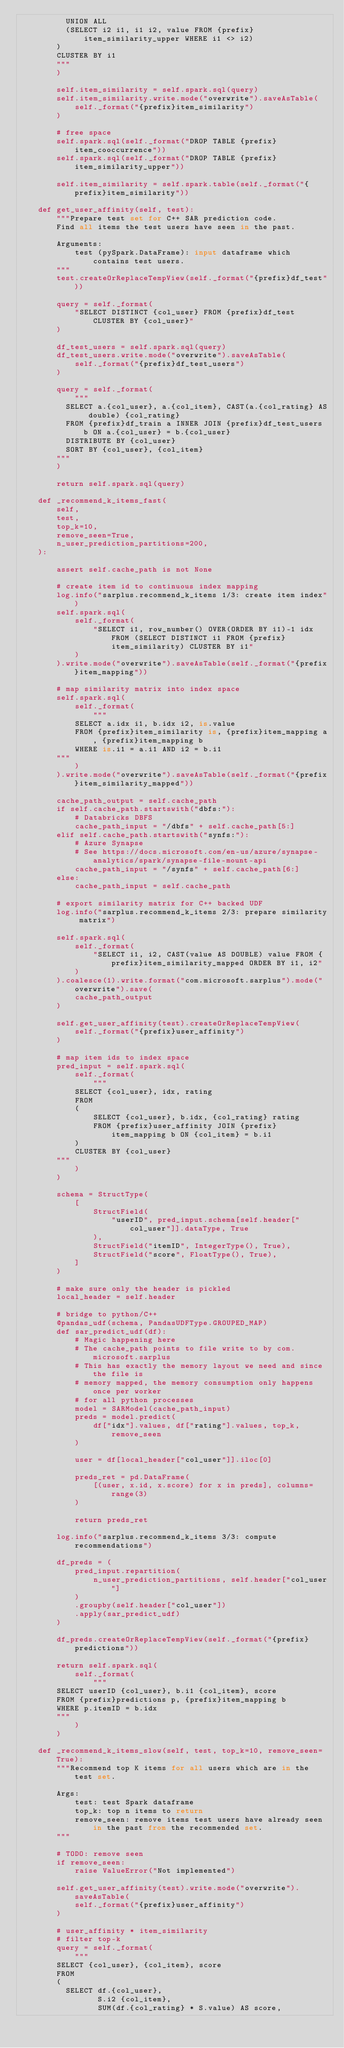<code> <loc_0><loc_0><loc_500><loc_500><_Python_>          UNION ALL
          (SELECT i2 i1, i1 i2, value FROM {prefix}item_similarity_upper WHERE i1 <> i2)
        )
        CLUSTER BY i1
        """
        )

        self.item_similarity = self.spark.sql(query)
        self.item_similarity.write.mode("overwrite").saveAsTable(
            self._format("{prefix}item_similarity")
        )

        # free space
        self.spark.sql(self._format("DROP TABLE {prefix}item_cooccurrence"))
        self.spark.sql(self._format("DROP TABLE {prefix}item_similarity_upper"))

        self.item_similarity = self.spark.table(self._format("{prefix}item_similarity"))

    def get_user_affinity(self, test):
        """Prepare test set for C++ SAR prediction code.
        Find all items the test users have seen in the past.

        Arguments:
            test (pySpark.DataFrame): input dataframe which contains test users.
        """
        test.createOrReplaceTempView(self._format("{prefix}df_test"))

        query = self._format(
            "SELECT DISTINCT {col_user} FROM {prefix}df_test CLUSTER BY {col_user}"
        )

        df_test_users = self.spark.sql(query)
        df_test_users.write.mode("overwrite").saveAsTable(
            self._format("{prefix}df_test_users")
        )

        query = self._format(
            """
          SELECT a.{col_user}, a.{col_item}, CAST(a.{col_rating} AS double) {col_rating}
          FROM {prefix}df_train a INNER JOIN {prefix}df_test_users b ON a.{col_user} = b.{col_user} 
          DISTRIBUTE BY {col_user}
          SORT BY {col_user}, {col_item}          
        """
        )

        return self.spark.sql(query)

    def _recommend_k_items_fast(
        self,
        test,
        top_k=10,
        remove_seen=True,
        n_user_prediction_partitions=200,
    ):

        assert self.cache_path is not None

        # create item id to continuous index mapping
        log.info("sarplus.recommend_k_items 1/3: create item index")
        self.spark.sql(
            self._format(
                "SELECT i1, row_number() OVER(ORDER BY i1)-1 idx FROM (SELECT DISTINCT i1 FROM {prefix}item_similarity) CLUSTER BY i1"
            )
        ).write.mode("overwrite").saveAsTable(self._format("{prefix}item_mapping"))

        # map similarity matrix into index space
        self.spark.sql(
            self._format(
                """
            SELECT a.idx i1, b.idx i2, is.value
            FROM {prefix}item_similarity is, {prefix}item_mapping a, {prefix}item_mapping b
            WHERE is.i1 = a.i1 AND i2 = b.i1
        """
            )
        ).write.mode("overwrite").saveAsTable(self._format("{prefix}item_similarity_mapped"))

        cache_path_output = self.cache_path
        if self.cache_path.startswith("dbfs:"):
            # Databricks DBFS
            cache_path_input = "/dbfs" + self.cache_path[5:]
        elif self.cache_path.startswith("synfs:"):
            # Azure Synapse
            # See https://docs.microsoft.com/en-us/azure/synapse-analytics/spark/synapse-file-mount-api
            cache_path_input = "/synfs" + self.cache_path[6:]
        else:
            cache_path_input = self.cache_path

        # export similarity matrix for C++ backed UDF
        log.info("sarplus.recommend_k_items 2/3: prepare similarity matrix")

        self.spark.sql(
            self._format(
                "SELECT i1, i2, CAST(value AS DOUBLE) value FROM {prefix}item_similarity_mapped ORDER BY i1, i2"
            )
        ).coalesce(1).write.format("com.microsoft.sarplus").mode("overwrite").save(
            cache_path_output
        )

        self.get_user_affinity(test).createOrReplaceTempView(
            self._format("{prefix}user_affinity")
        )

        # map item ids to index space
        pred_input = self.spark.sql(
            self._format(
                """
            SELECT {col_user}, idx, rating
            FROM 
            (
                SELECT {col_user}, b.idx, {col_rating} rating
                FROM {prefix}user_affinity JOIN {prefix}item_mapping b ON {col_item} = b.i1 
            )
            CLUSTER BY {col_user}
        """
            )
        )

        schema = StructType(
            [
                StructField(
                    "userID", pred_input.schema[self.header["col_user"]].dataType, True
                ),
                StructField("itemID", IntegerType(), True),
                StructField("score", FloatType(), True),
            ]
        )

        # make sure only the header is pickled
        local_header = self.header

        # bridge to python/C++
        @pandas_udf(schema, PandasUDFType.GROUPED_MAP)
        def sar_predict_udf(df):
            # Magic happening here
            # The cache_path points to file write to by com.microsoft.sarplus
            # This has exactly the memory layout we need and since the file is
            # memory mapped, the memory consumption only happens once per worker
            # for all python processes
            model = SARModel(cache_path_input)
            preds = model.predict(
                df["idx"].values, df["rating"].values, top_k, remove_seen
            )

            user = df[local_header["col_user"]].iloc[0]

            preds_ret = pd.DataFrame(
                [(user, x.id, x.score) for x in preds], columns=range(3)
            )

            return preds_ret

        log.info("sarplus.recommend_k_items 3/3: compute recommendations")

        df_preds = (
            pred_input.repartition(
                n_user_prediction_partitions, self.header["col_user"]
            )
            .groupby(self.header["col_user"])
            .apply(sar_predict_udf)
        )

        df_preds.createOrReplaceTempView(self._format("{prefix}predictions"))

        return self.spark.sql(
            self._format(
                """
        SELECT userID {col_user}, b.i1 {col_item}, score
        FROM {prefix}predictions p, {prefix}item_mapping b
        WHERE p.itemID = b.idx
        """
            )
        )

    def _recommend_k_items_slow(self, test, top_k=10, remove_seen=True):
        """Recommend top K items for all users which are in the test set.

        Args:
            test: test Spark dataframe
            top_k: top n items to return
            remove_seen: remove items test users have already seen in the past from the recommended set.
        """

        # TODO: remove seen
        if remove_seen:
            raise ValueError("Not implemented")

        self.get_user_affinity(test).write.mode("overwrite").saveAsTable(
            self._format("{prefix}user_affinity")
        )

        # user_affinity * item_similarity
        # filter top-k
        query = self._format(
            """
        SELECT {col_user}, {col_item}, score
        FROM
        (
          SELECT df.{col_user},
                 S.i2 {col_item},
                 SUM(df.{col_rating} * S.value) AS score,</code> 